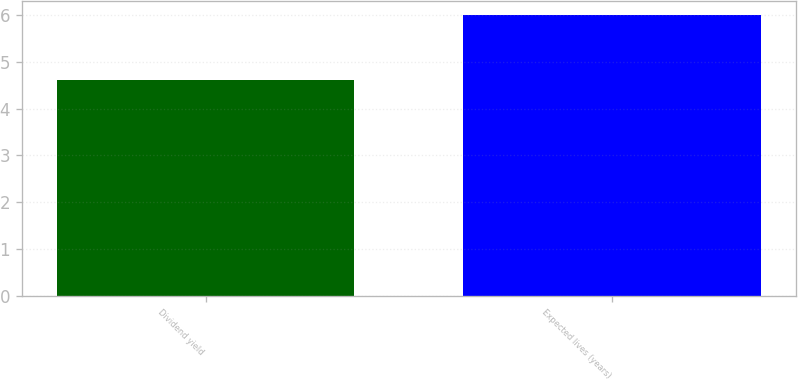Convert chart. <chart><loc_0><loc_0><loc_500><loc_500><bar_chart><fcel>Dividend yield<fcel>Expected lives (years)<nl><fcel>4.6<fcel>6<nl></chart> 